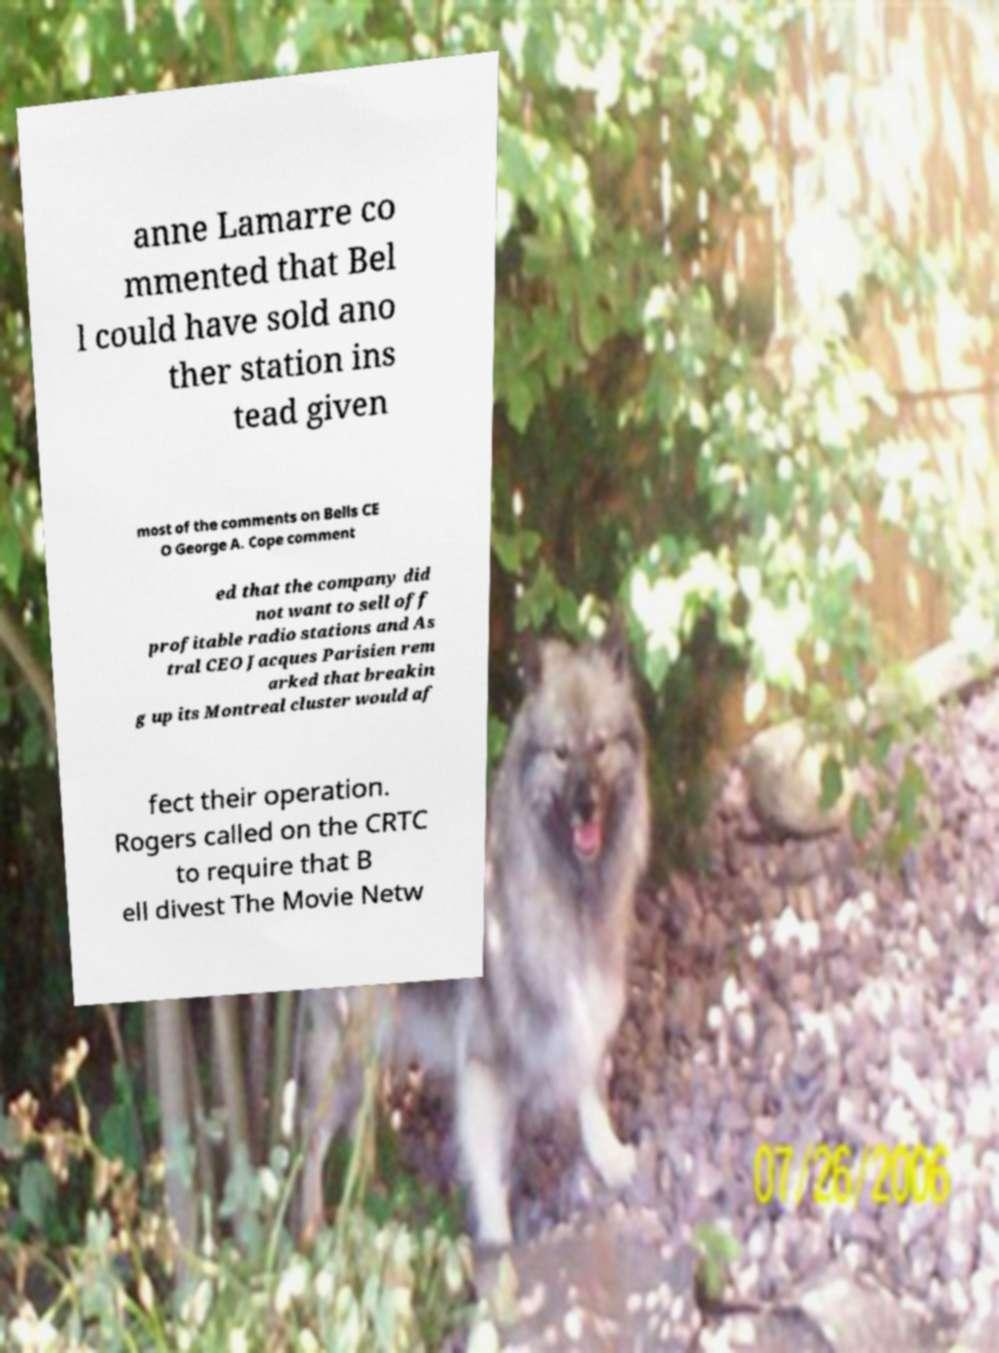There's text embedded in this image that I need extracted. Can you transcribe it verbatim? anne Lamarre co mmented that Bel l could have sold ano ther station ins tead given most of the comments on Bells CE O George A. Cope comment ed that the company did not want to sell off profitable radio stations and As tral CEO Jacques Parisien rem arked that breakin g up its Montreal cluster would af fect their operation. Rogers called on the CRTC to require that B ell divest The Movie Netw 